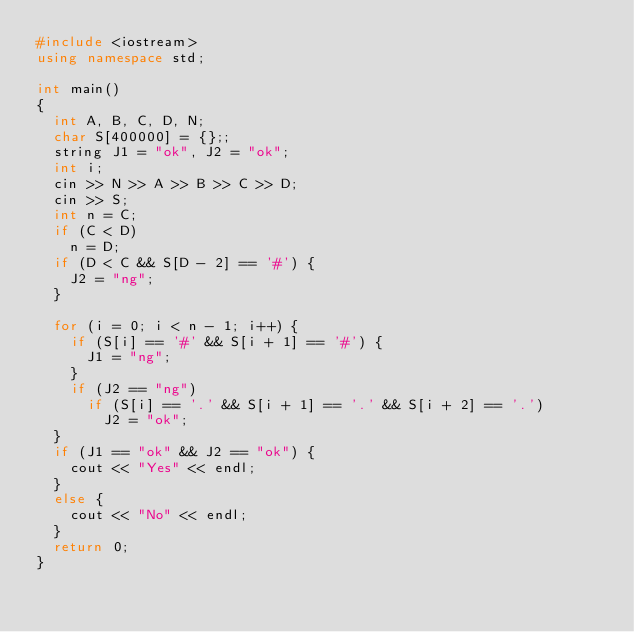Convert code to text. <code><loc_0><loc_0><loc_500><loc_500><_C++_>#include <iostream>
using namespace std;

int main()
{
	int A, B, C, D, N;
	char S[400000] = {};;
	string J1 = "ok", J2 = "ok";
	int i;
	cin >> N >> A >> B >> C >> D;
	cin >> S;
	int n = C;
	if (C < D)
		n = D;
	if (D < C && S[D - 2] == '#') {
		J2 = "ng";
	}

	for (i = 0; i < n - 1; i++) {
		if (S[i] == '#' && S[i + 1] == '#') {
			J1 = "ng";
		}
		if (J2 == "ng")
			if (S[i] == '.' && S[i + 1] == '.' && S[i + 2] == '.')
				J2 = "ok";
	}
	if (J1 == "ok" && J2 == "ok") {
		cout << "Yes" << endl;
	}
	else {
		cout << "No" << endl;
	}
	return 0;
}</code> 